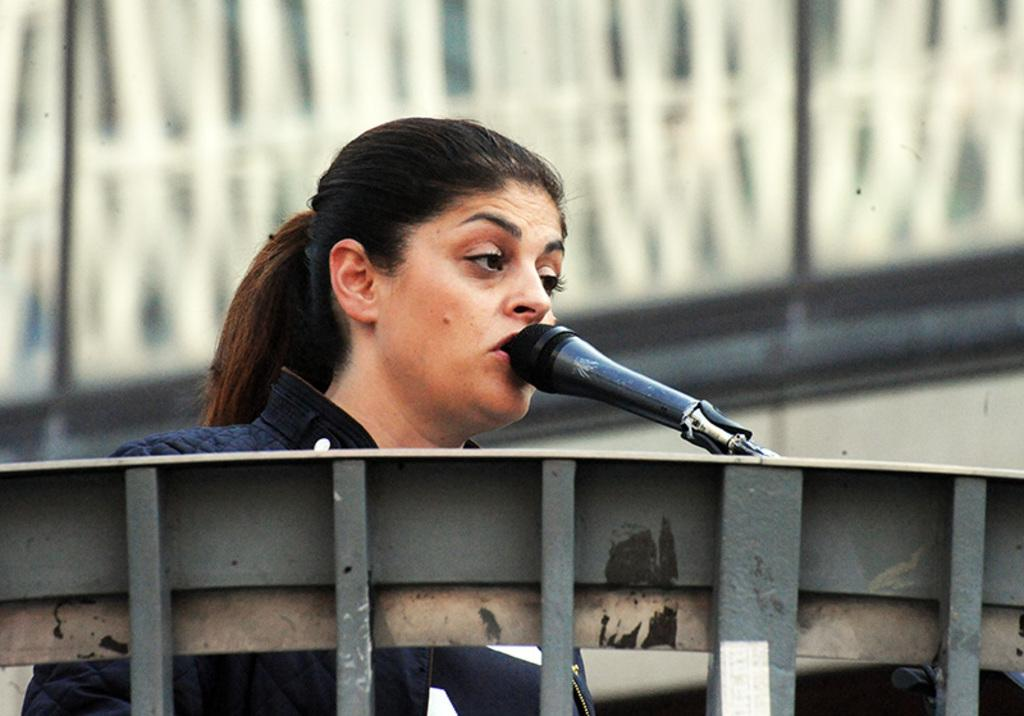Who is the main subject in the image? There is a woman in the image. What is the woman doing in the image? The woman is talking into a microphone. Can you describe the background of the image? The background of the image is blurred. What type of finger can be seen holding a quill in the image? There is no finger or quill present in the image. Can you describe the ocean in the image? There is no ocean present in the image. 